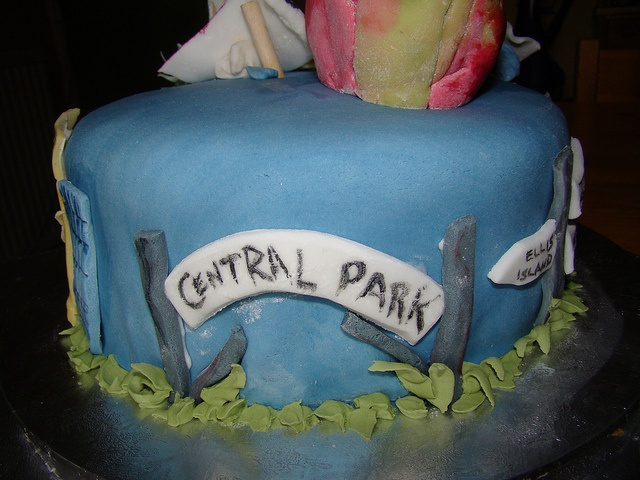Describe the objects in this image and their specific colors. I can see a cake in black, gray, and blue tones in this image. 